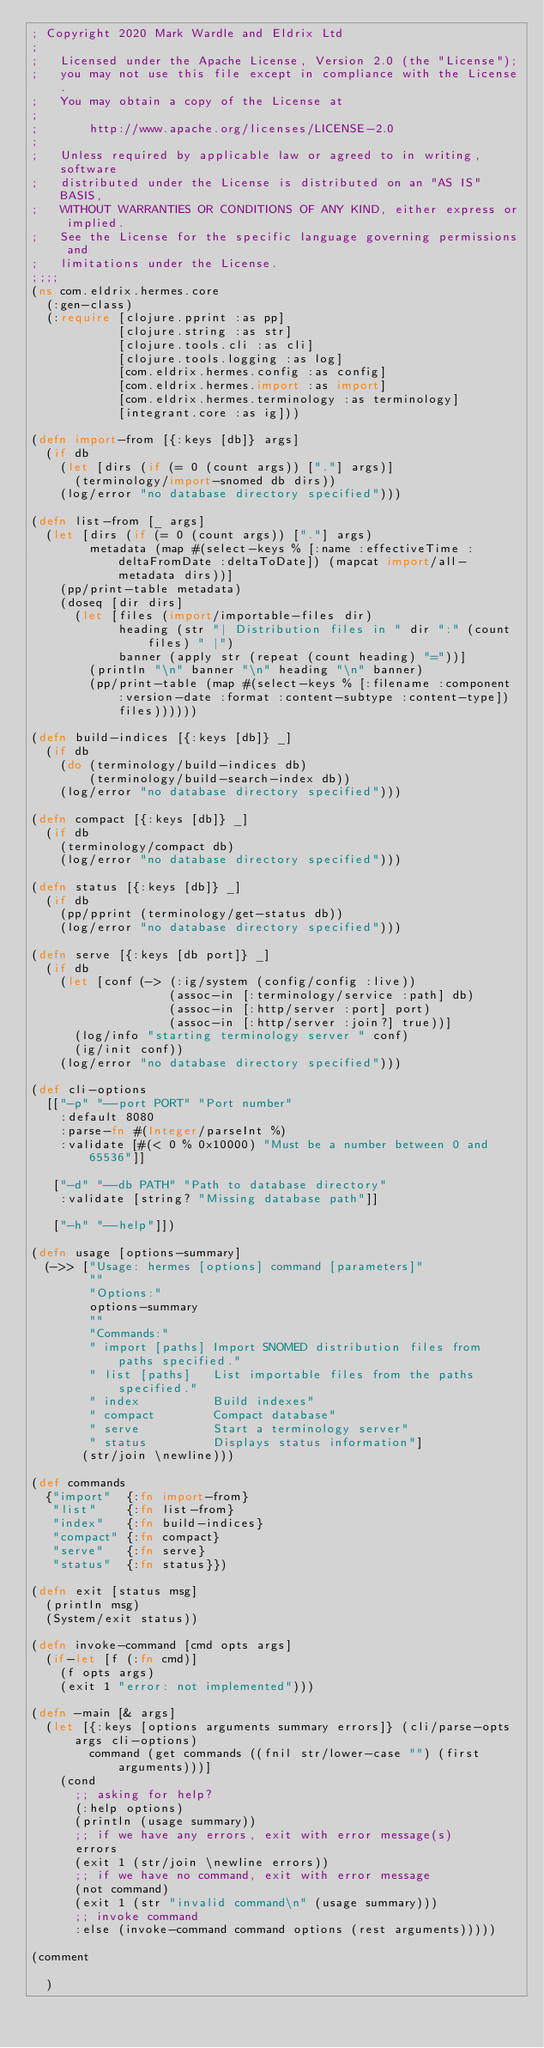Convert code to text. <code><loc_0><loc_0><loc_500><loc_500><_Clojure_>; Copyright 2020 Mark Wardle and Eldrix Ltd
;
;   Licensed under the Apache License, Version 2.0 (the "License");
;   you may not use this file except in compliance with the License.
;   You may obtain a copy of the License at
;
;       http://www.apache.org/licenses/LICENSE-2.0
;
;   Unless required by applicable law or agreed to in writing, software
;   distributed under the License is distributed on an "AS IS" BASIS,
;   WITHOUT WARRANTIES OR CONDITIONS OF ANY KIND, either express or implied.
;   See the License for the specific language governing permissions and
;   limitations under the License.
;;;;
(ns com.eldrix.hermes.core
  (:gen-class)
  (:require [clojure.pprint :as pp]
            [clojure.string :as str]
            [clojure.tools.cli :as cli]
            [clojure.tools.logging :as log]
            [com.eldrix.hermes.config :as config]
            [com.eldrix.hermes.import :as import]
            [com.eldrix.hermes.terminology :as terminology]
            [integrant.core :as ig]))

(defn import-from [{:keys [db]} args]
  (if db
    (let [dirs (if (= 0 (count args)) ["."] args)]
      (terminology/import-snomed db dirs))
    (log/error "no database directory specified")))

(defn list-from [_ args]
  (let [dirs (if (= 0 (count args)) ["."] args)
        metadata (map #(select-keys % [:name :effectiveTime :deltaFromDate :deltaToDate]) (mapcat import/all-metadata dirs))]
    (pp/print-table metadata)
    (doseq [dir dirs]
      (let [files (import/importable-files dir)
            heading (str "| Distribution files in " dir ":" (count files) " |")
            banner (apply str (repeat (count heading) "="))]
        (println "\n" banner "\n" heading "\n" banner)
        (pp/print-table (map #(select-keys % [:filename :component :version-date :format :content-subtype :content-type]) files))))))

(defn build-indices [{:keys [db]} _]
  (if db
    (do (terminology/build-indices db)
        (terminology/build-search-index db))
    (log/error "no database directory specified")))

(defn compact [{:keys [db]} _]
  (if db
    (terminology/compact db)
    (log/error "no database directory specified")))

(defn status [{:keys [db]} _]
  (if db
    (pp/pprint (terminology/get-status db))
    (log/error "no database directory specified")))

(defn serve [{:keys [db port]} _]
  (if db
    (let [conf (-> (:ig/system (config/config :live))
                   (assoc-in [:terminology/service :path] db)
                   (assoc-in [:http/server :port] port)
                   (assoc-in [:http/server :join?] true))]
      (log/info "starting terminology server " conf)
      (ig/init conf))
    (log/error "no database directory specified")))

(def cli-options
  [["-p" "--port PORT" "Port number"
    :default 8080
    :parse-fn #(Integer/parseInt %)
    :validate [#(< 0 % 0x10000) "Must be a number between 0 and 65536"]]

   ["-d" "--db PATH" "Path to database directory"
    :validate [string? "Missing database path"]]

   ["-h" "--help"]])

(defn usage [options-summary]
  (->> ["Usage: hermes [options] command [parameters]"
        ""
        "Options:"
        options-summary
        ""
        "Commands:"
        " import [paths] Import SNOMED distribution files from paths specified."
        " list [paths]   List importable files from the paths specified."
        " index          Build indexes"
        " compact        Compact database"
        " serve          Start a terminology server"
        " status         Displays status information"]
       (str/join \newline)))

(def commands
  {"import"  {:fn import-from}
   "list"    {:fn list-from}
   "index"   {:fn build-indices}
   "compact" {:fn compact}
   "serve"   {:fn serve}
   "status"  {:fn status}})

(defn exit [status msg]
  (println msg)
  (System/exit status))

(defn invoke-command [cmd opts args]
  (if-let [f (:fn cmd)]
    (f opts args)
    (exit 1 "error: not implemented")))

(defn -main [& args]
  (let [{:keys [options arguments summary errors]} (cli/parse-opts args cli-options)
        command (get commands ((fnil str/lower-case "") (first arguments)))]
    (cond
      ;; asking for help?
      (:help options)
      (println (usage summary))
      ;; if we have any errors, exit with error message(s)
      errors
      (exit 1 (str/join \newline errors))
      ;; if we have no command, exit with error message
      (not command)
      (exit 1 (str "invalid command\n" (usage summary)))
      ;; invoke command
      :else (invoke-command command options (rest arguments)))))

(comment

  )</code> 